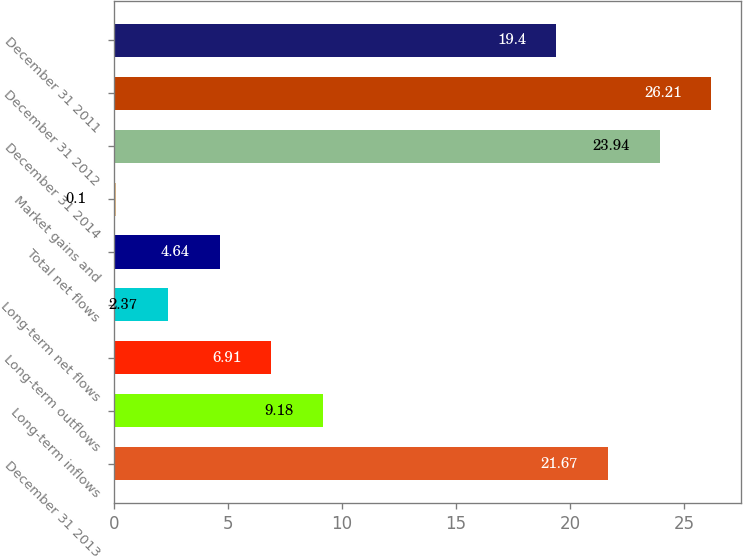Convert chart. <chart><loc_0><loc_0><loc_500><loc_500><bar_chart><fcel>December 31 2013<fcel>Long-term inflows<fcel>Long-term outflows<fcel>Long-term net flows<fcel>Total net flows<fcel>Market gains and<fcel>December 31 2014<fcel>December 31 2012<fcel>December 31 2011<nl><fcel>21.67<fcel>9.18<fcel>6.91<fcel>2.37<fcel>4.64<fcel>0.1<fcel>23.94<fcel>26.21<fcel>19.4<nl></chart> 